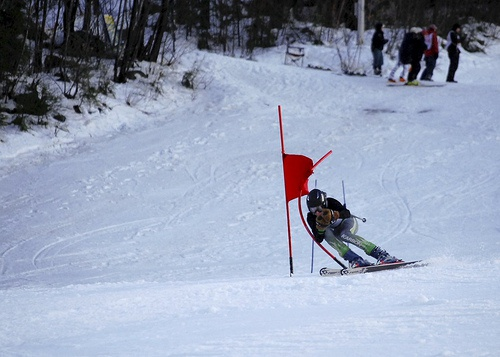Describe the objects in this image and their specific colors. I can see people in black, gray, navy, and darkgray tones, people in black, maroon, and purple tones, people in black and gray tones, people in black and gray tones, and people in black and gray tones in this image. 